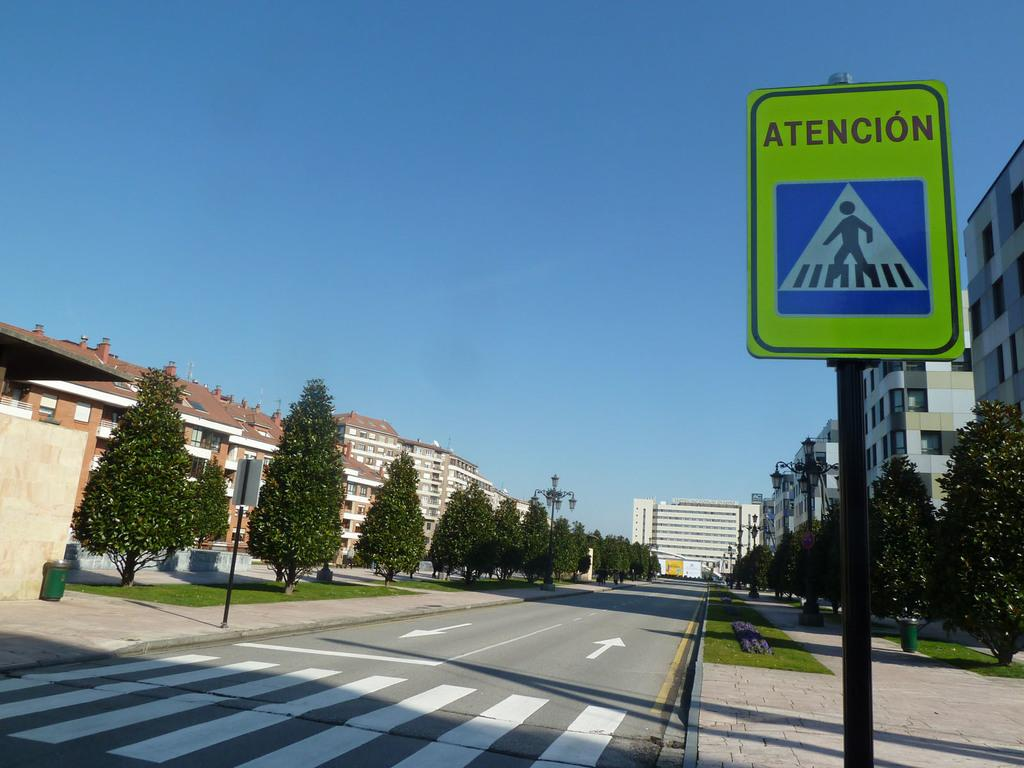Provide a one-sentence caption for the provided image. A crosswalk has a sign on the right that displays Atencion. 